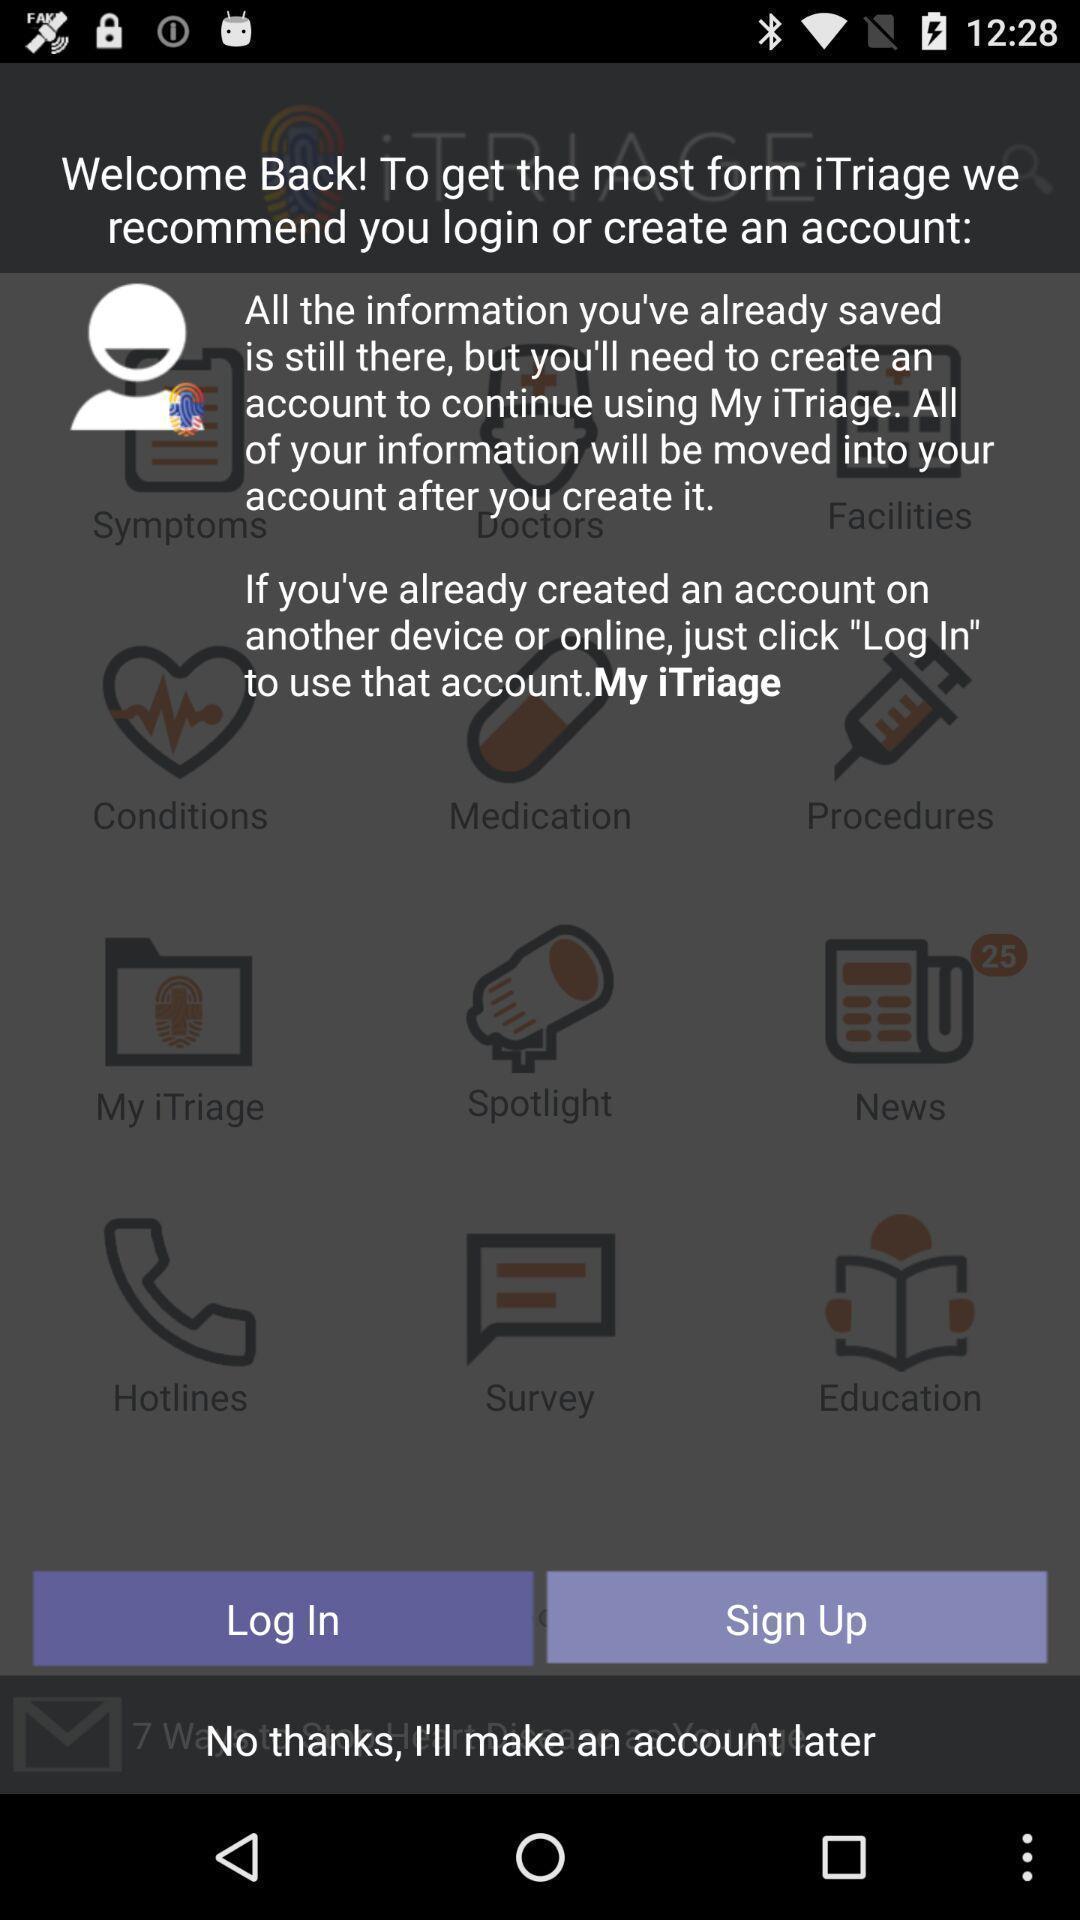Describe the content in this image. Welcome screen. 